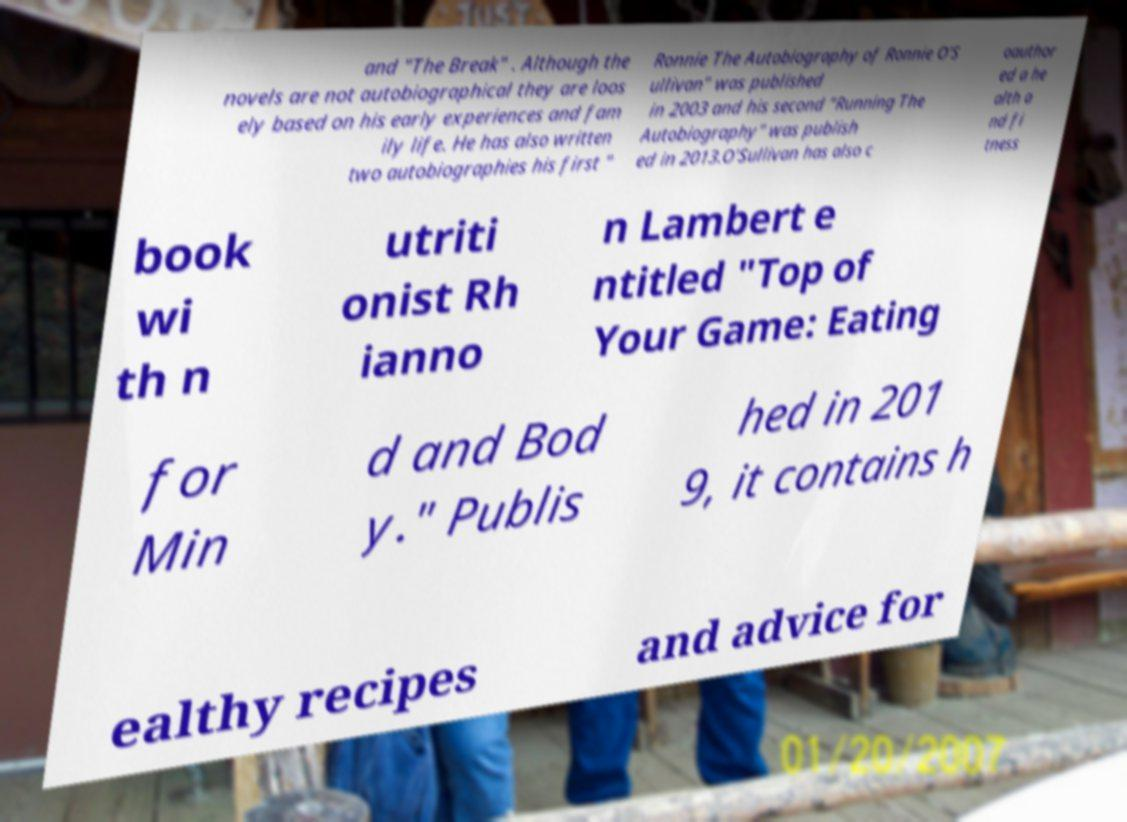Please read and relay the text visible in this image. What does it say? and "The Break" . Although the novels are not autobiographical they are loos ely based on his early experiences and fam ily life. He has also written two autobiographies his first " Ronnie The Autobiography of Ronnie O'S ullivan" was published in 2003 and his second "Running The Autobiography" was publish ed in 2013.O'Sullivan has also c oauthor ed a he alth a nd fi tness book wi th n utriti onist Rh ianno n Lambert e ntitled "Top of Your Game: Eating for Min d and Bod y." Publis hed in 201 9, it contains h ealthy recipes and advice for 